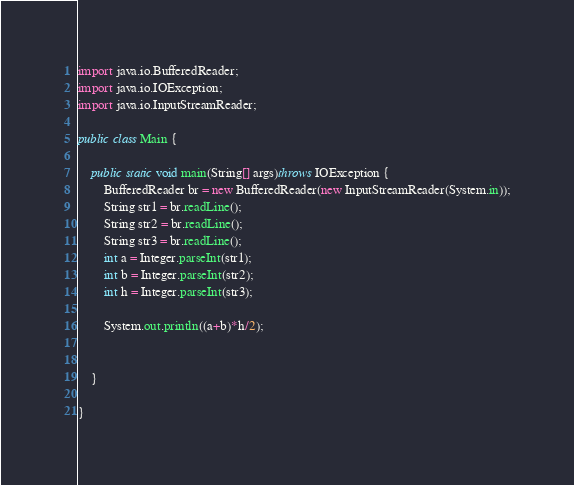<code> <loc_0><loc_0><loc_500><loc_500><_Java_>import java.io.BufferedReader;
import java.io.IOException;
import java.io.InputStreamReader;

public class Main {

	public static void main(String[] args)throws IOException {
		BufferedReader br = new BufferedReader(new InputStreamReader(System.in));
		String str1 = br.readLine();
		String str2 = br.readLine();
		String str3 = br.readLine();
		int a = Integer.parseInt(str1);
		int b = Integer.parseInt(str2);
		int h = Integer.parseInt(str3);
		
		System.out.println((a+b)*h/2);
		

	}

}
</code> 